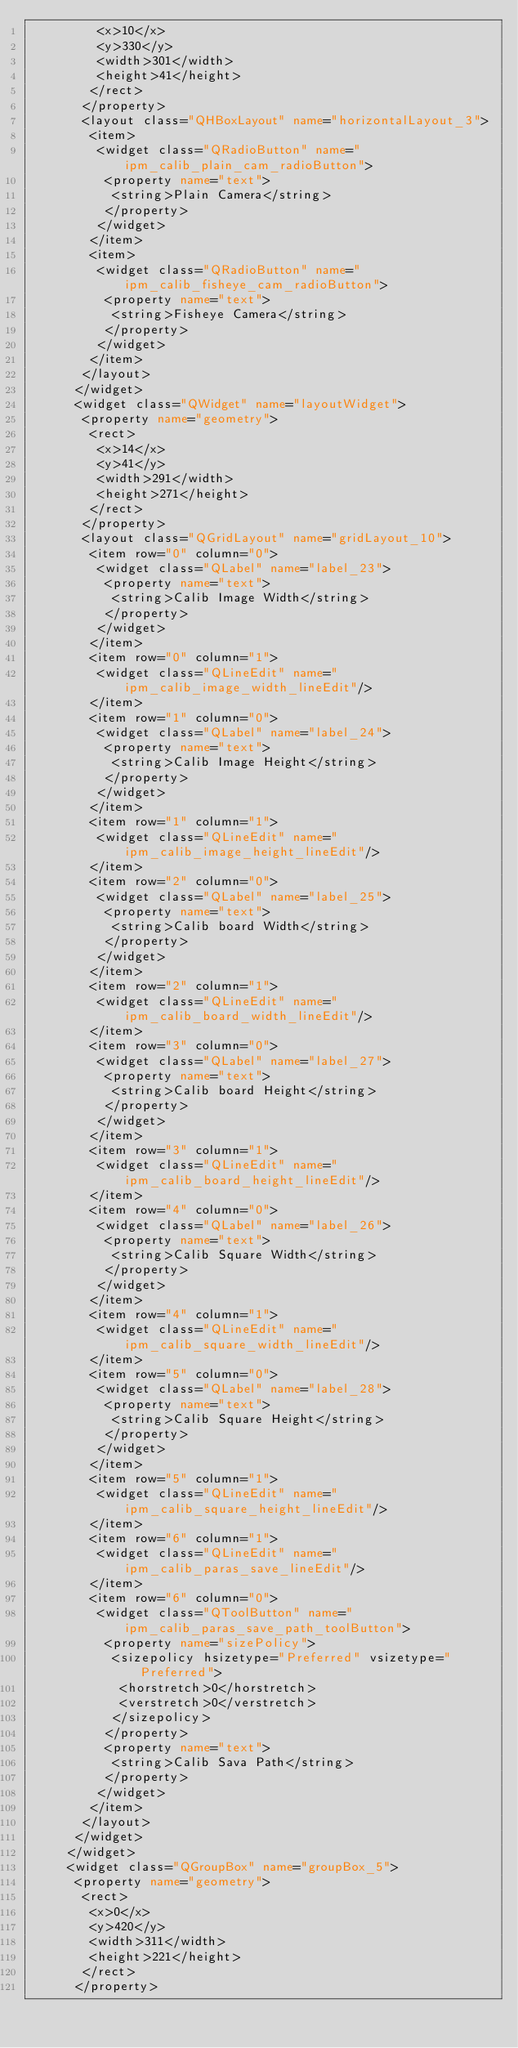Convert code to text. <code><loc_0><loc_0><loc_500><loc_500><_XML_>         <x>10</x>
         <y>330</y>
         <width>301</width>
         <height>41</height>
        </rect>
       </property>
       <layout class="QHBoxLayout" name="horizontalLayout_3">
        <item>
         <widget class="QRadioButton" name="ipm_calib_plain_cam_radioButton">
          <property name="text">
           <string>Plain Camera</string>
          </property>
         </widget>
        </item>
        <item>
         <widget class="QRadioButton" name="ipm_calib_fisheye_cam_radioButton">
          <property name="text">
           <string>Fisheye Camera</string>
          </property>
         </widget>
        </item>
       </layout>
      </widget>
      <widget class="QWidget" name="layoutWidget">
       <property name="geometry">
        <rect>
         <x>14</x>
         <y>41</y>
         <width>291</width>
         <height>271</height>
        </rect>
       </property>
       <layout class="QGridLayout" name="gridLayout_10">
        <item row="0" column="0">
         <widget class="QLabel" name="label_23">
          <property name="text">
           <string>Calib Image Width</string>
          </property>
         </widget>
        </item>
        <item row="0" column="1">
         <widget class="QLineEdit" name="ipm_calib_image_width_lineEdit"/>
        </item>
        <item row="1" column="0">
         <widget class="QLabel" name="label_24">
          <property name="text">
           <string>Calib Image Height</string>
          </property>
         </widget>
        </item>
        <item row="1" column="1">
         <widget class="QLineEdit" name="ipm_calib_image_height_lineEdit"/>
        </item>
        <item row="2" column="0">
         <widget class="QLabel" name="label_25">
          <property name="text">
           <string>Calib board Width</string>
          </property>
         </widget>
        </item>
        <item row="2" column="1">
         <widget class="QLineEdit" name="ipm_calib_board_width_lineEdit"/>
        </item>
        <item row="3" column="0">
         <widget class="QLabel" name="label_27">
          <property name="text">
           <string>Calib board Height</string>
          </property>
         </widget>
        </item>
        <item row="3" column="1">
         <widget class="QLineEdit" name="ipm_calib_board_height_lineEdit"/>
        </item>
        <item row="4" column="0">
         <widget class="QLabel" name="label_26">
          <property name="text">
           <string>Calib Square Width</string>
          </property>
         </widget>
        </item>
        <item row="4" column="1">
         <widget class="QLineEdit" name="ipm_calib_square_width_lineEdit"/>
        </item>
        <item row="5" column="0">
         <widget class="QLabel" name="label_28">
          <property name="text">
           <string>Calib Square Height</string>
          </property>
         </widget>
        </item>
        <item row="5" column="1">
         <widget class="QLineEdit" name="ipm_calib_square_height_lineEdit"/>
        </item>
        <item row="6" column="1">
         <widget class="QLineEdit" name="ipm_calib_paras_save_lineEdit"/>
        </item>
        <item row="6" column="0">
         <widget class="QToolButton" name="ipm_calib_paras_save_path_toolButton">
          <property name="sizePolicy">
           <sizepolicy hsizetype="Preferred" vsizetype="Preferred">
            <horstretch>0</horstretch>
            <verstretch>0</verstretch>
           </sizepolicy>
          </property>
          <property name="text">
           <string>Calib Sava Path</string>
          </property>
         </widget>
        </item>
       </layout>
      </widget>
     </widget>
     <widget class="QGroupBox" name="groupBox_5">
      <property name="geometry">
       <rect>
        <x>0</x>
        <y>420</y>
        <width>311</width>
        <height>221</height>
       </rect>
      </property></code> 